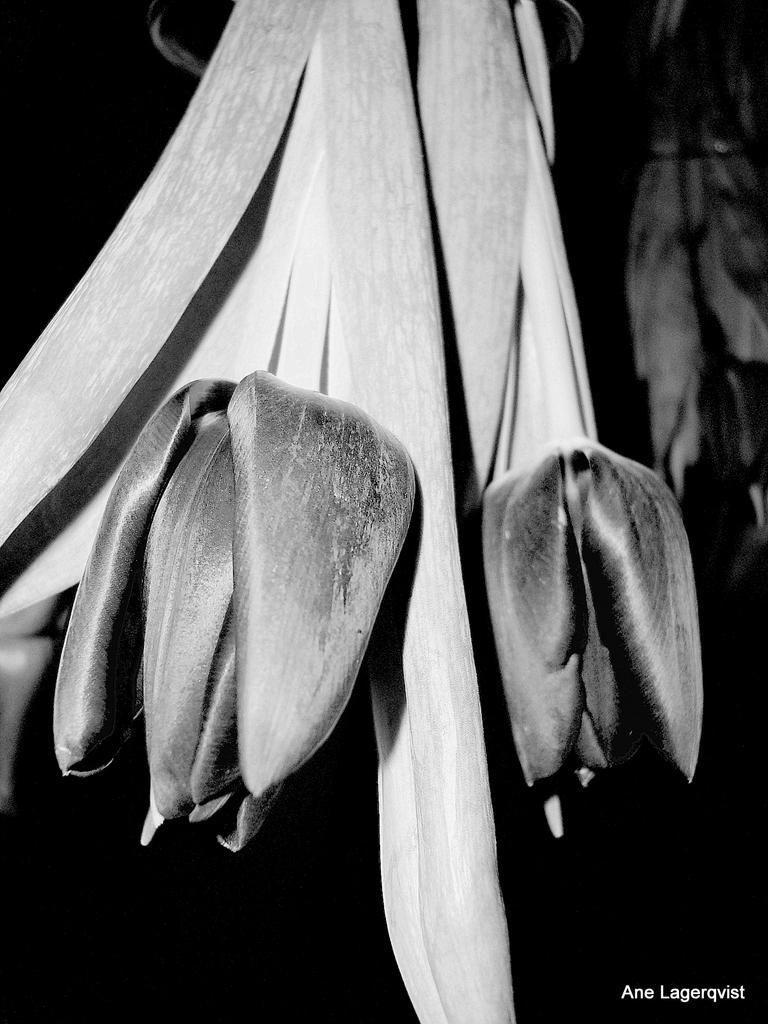Describe this image in one or two sentences. In this black and white picture there are flowers and leaves. 